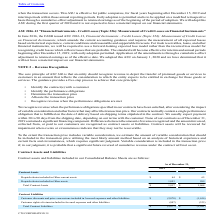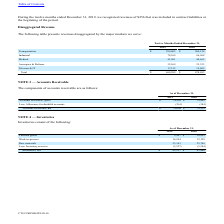From Cts Corporation's financial document, Which years does the table provide information for the company's Contract assets and liabilities? The document shows two values: 2019 and 2018. From the document: "2019 2018 2019 2018..." Also, What were the Prepaid rebates included in Other current assets in 2019? According to the financial document, 64 (in thousands). The relevant text states: "repaid rebates included in Other current assets $ 64 $ 65..." Also, What were the Prepaid rebates included in Other assets in 2018? According to the financial document, 999 (in thousands). The relevant text states: "Prepaid rebates included in Other assets 1,853 999..." Also, How many years did total contract assets exceed $1,500 thousand? Based on the analysis, there are 1 instances. The counting process: 2019. Also, can you calculate: What was the change in the Prepaid rebates included in Other assets between 2018 and 2019? Based on the calculation: 1,853-999, the result is 854 (in thousands). This is based on the information: "Prepaid rebates included in Other assets 1,853 999 Prepaid rebates included in Other assets 1,853 999..." The key data points involved are: 1,853, 999. Also, can you calculate: What was the percentage change in total contract liabilities between 2018 and 2019? To answer this question, I need to perform calculations using the financial data. The calculation is: (-2,877-(-1,981))/-1,981, which equals 45.23 (percentage). This is based on the information: "Total Contract Liabilities $ (2,877) $ (1,981) Total Contract Liabilities $ (2,877) $ (1,981)..." The key data points involved are: 1,981, 2,877. 